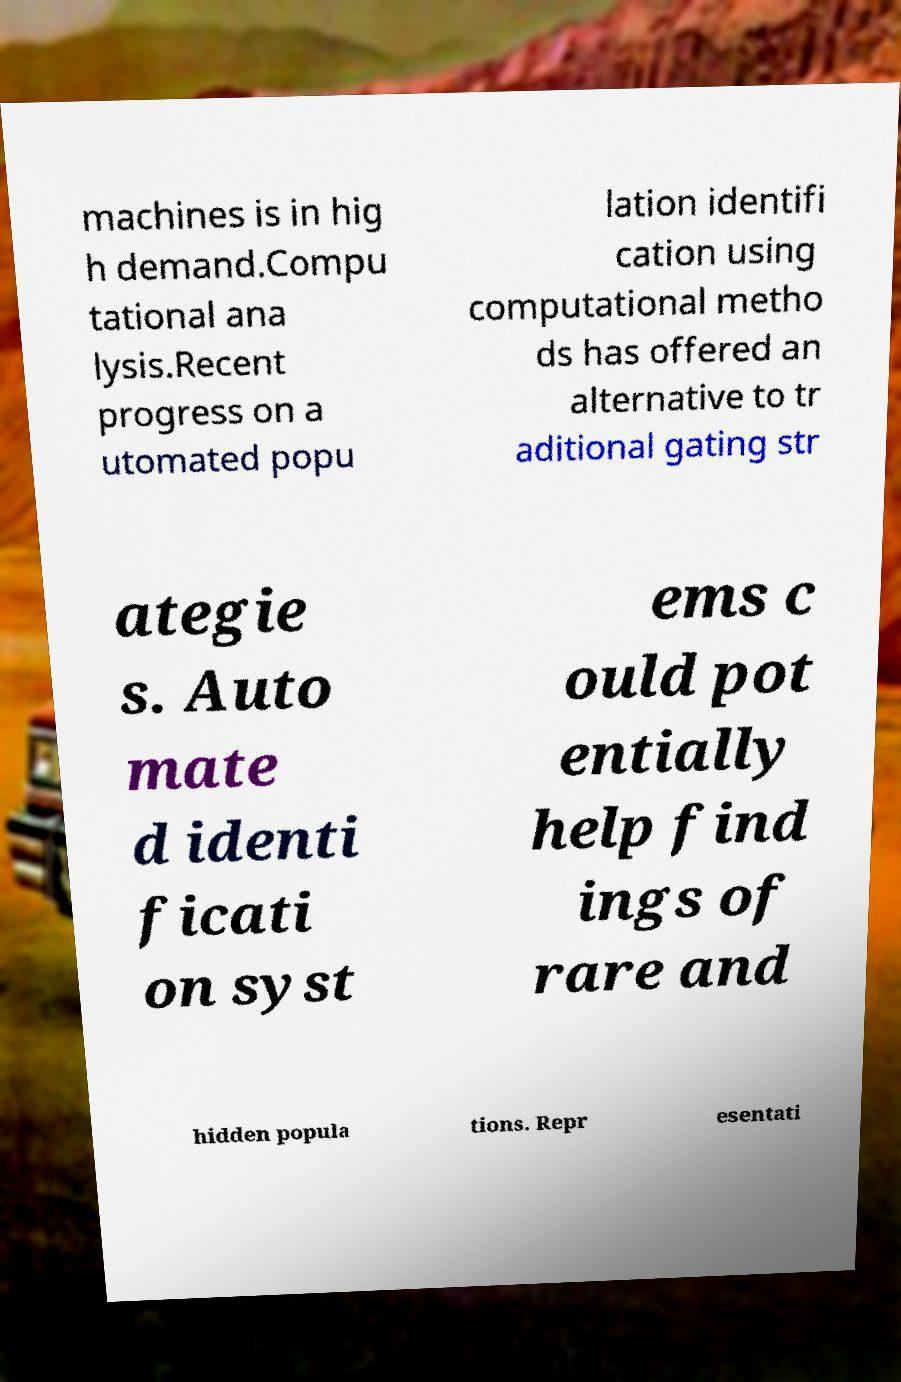For documentation purposes, I need the text within this image transcribed. Could you provide that? machines is in hig h demand.Compu tational ana lysis.Recent progress on a utomated popu lation identifi cation using computational metho ds has offered an alternative to tr aditional gating str ategie s. Auto mate d identi ficati on syst ems c ould pot entially help find ings of rare and hidden popula tions. Repr esentati 